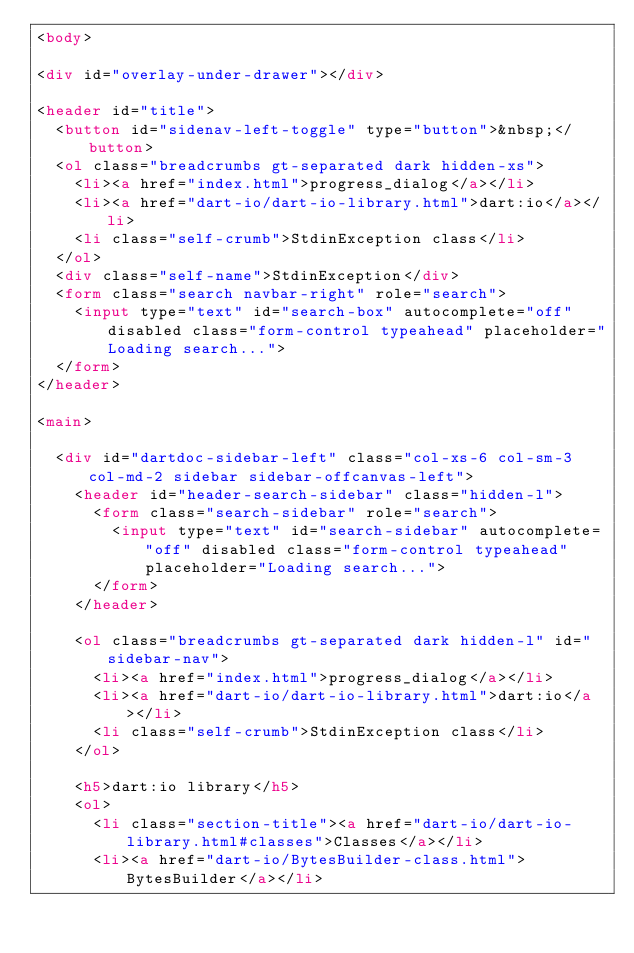Convert code to text. <code><loc_0><loc_0><loc_500><loc_500><_HTML_><body>

<div id="overlay-under-drawer"></div>

<header id="title">
  <button id="sidenav-left-toggle" type="button">&nbsp;</button>
  <ol class="breadcrumbs gt-separated dark hidden-xs">
    <li><a href="index.html">progress_dialog</a></li>
    <li><a href="dart-io/dart-io-library.html">dart:io</a></li>
    <li class="self-crumb">StdinException class</li>
  </ol>
  <div class="self-name">StdinException</div>
  <form class="search navbar-right" role="search">
    <input type="text" id="search-box" autocomplete="off" disabled class="form-control typeahead" placeholder="Loading search...">
  </form>
</header>

<main>

  <div id="dartdoc-sidebar-left" class="col-xs-6 col-sm-3 col-md-2 sidebar sidebar-offcanvas-left">
    <header id="header-search-sidebar" class="hidden-l">
      <form class="search-sidebar" role="search">
        <input type="text" id="search-sidebar" autocomplete="off" disabled class="form-control typeahead" placeholder="Loading search...">
      </form>
    </header>
    
    <ol class="breadcrumbs gt-separated dark hidden-l" id="sidebar-nav">
      <li><a href="index.html">progress_dialog</a></li>
      <li><a href="dart-io/dart-io-library.html">dart:io</a></li>
      <li class="self-crumb">StdinException class</li>
    </ol>
    
    <h5>dart:io library</h5>
    <ol>
      <li class="section-title"><a href="dart-io/dart-io-library.html#classes">Classes</a></li>
      <li><a href="dart-io/BytesBuilder-class.html">BytesBuilder</a></li></code> 